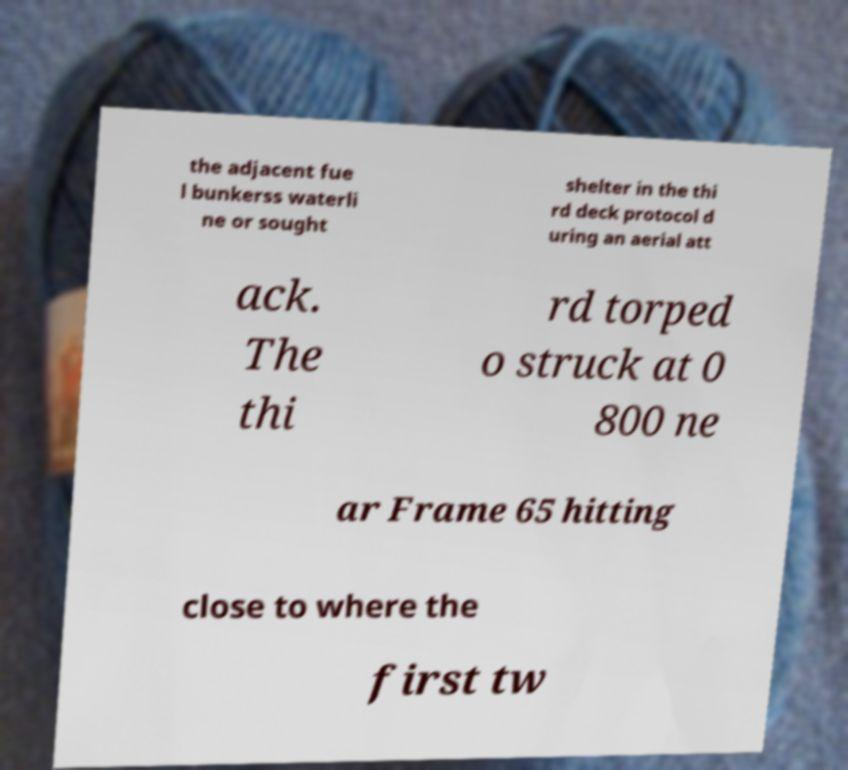Please read and relay the text visible in this image. What does it say? the adjacent fue l bunkerss waterli ne or sought shelter in the thi rd deck protocol d uring an aerial att ack. The thi rd torped o struck at 0 800 ne ar Frame 65 hitting close to where the first tw 